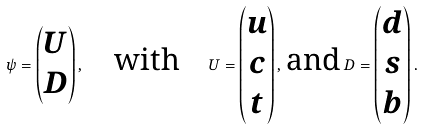<formula> <loc_0><loc_0><loc_500><loc_500>\psi = \begin{pmatrix} U \\ D \end{pmatrix} , \quad \text {with} \quad U = \begin{pmatrix} u \\ c \\ t \end{pmatrix} , \, \text {and} \, D = \begin{pmatrix} d \\ s \\ b \end{pmatrix} .</formula> 